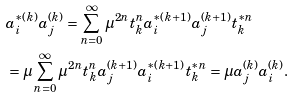Convert formula to latex. <formula><loc_0><loc_0><loc_500><loc_500>& a _ { i } ^ { * ( k ) } a _ { j } ^ { ( k ) } = \sum _ { n = 0 } ^ { \infty } \mu ^ { 2 n } t _ { k } ^ { n } a _ { i } ^ { * ( k + 1 ) } a _ { j } ^ { ( k + 1 ) } t _ { k } ^ { * n } \\ & = \mu \sum _ { n = 0 } ^ { \infty } \mu ^ { 2 n } t _ { k } ^ { n } a _ { j } ^ { ( k + 1 ) } a _ { i } ^ { * ( k + 1 ) } t _ { k } ^ { * n } = \mu a _ { j } ^ { ( k ) } a _ { i } ^ { ( k ) } .</formula> 